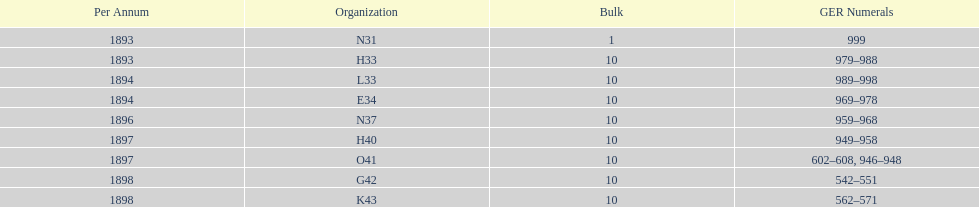What amount of time to the years span? 5 years. 